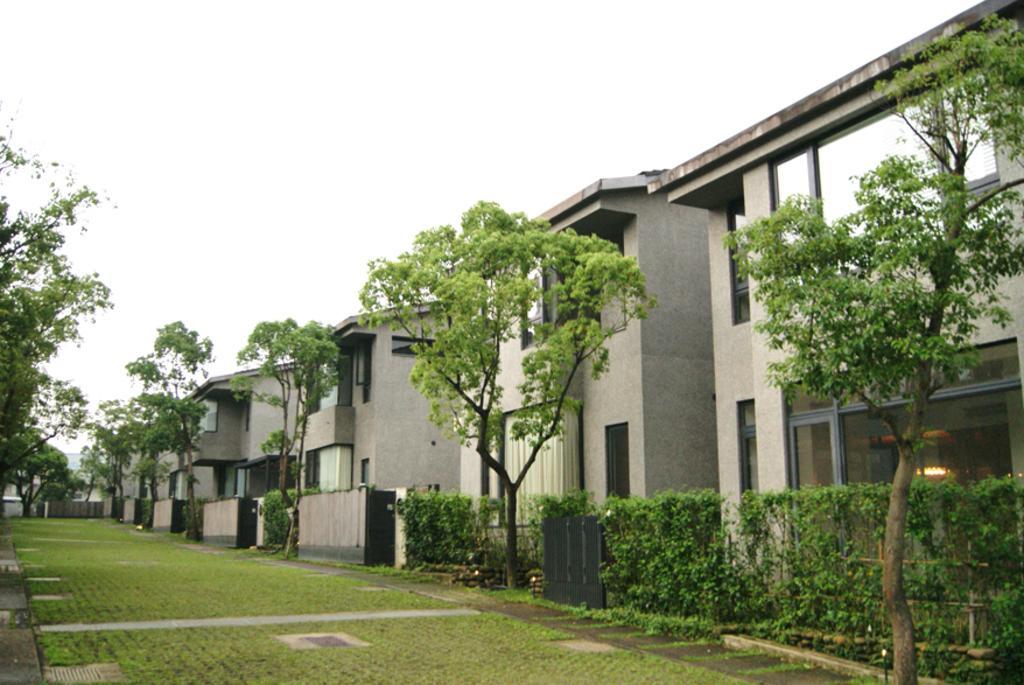Could you give a brief overview of what you see in this image? The picture which is taken outside of the houses. The houses are in same design. The house is in ash color and it as fence and black gate. The plants are in-front of houses. The trees are also in-front of houses and are in green color. The grass is in-front of house. The sky is in white color. The light is inside the house. There is a window with building. 